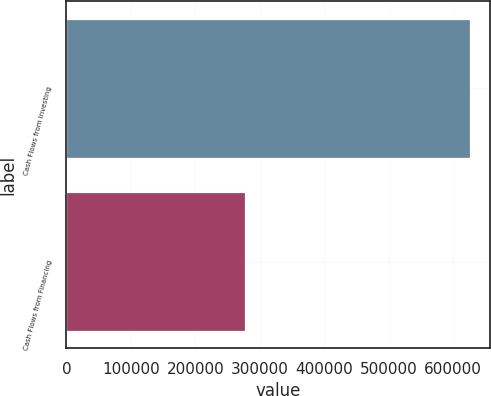Convert chart to OTSL. <chart><loc_0><loc_0><loc_500><loc_500><bar_chart><fcel>Cash Flows from Investing<fcel>Cash Flows from Financing<nl><fcel>626523<fcel>276569<nl></chart> 